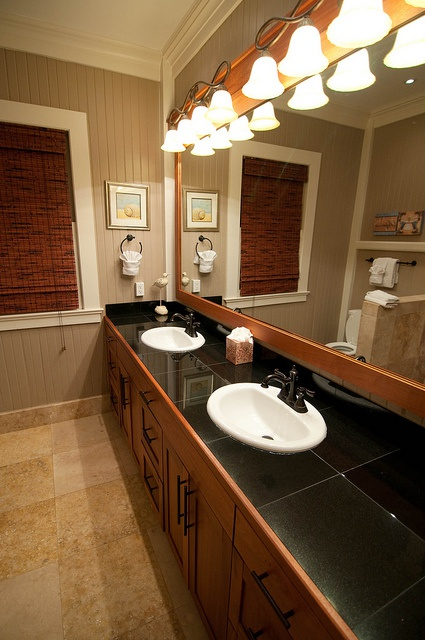Describe the objects in this image and their specific colors. I can see sink in olive, ivory, black, lightgray, and gray tones, sink in olive, ivory, lightgray, darkgray, and gray tones, and toilet in olive, tan, and gray tones in this image. 